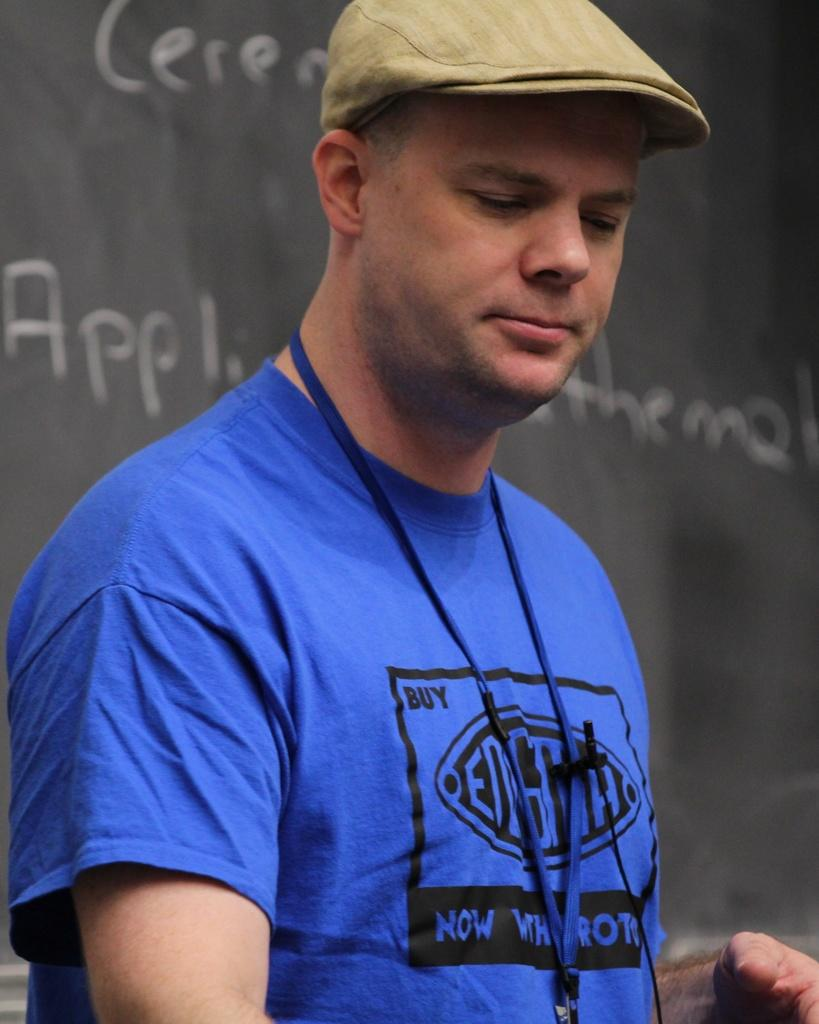Provide a one-sentence caption for the provided image. a man with the word now in his blue shirt. 